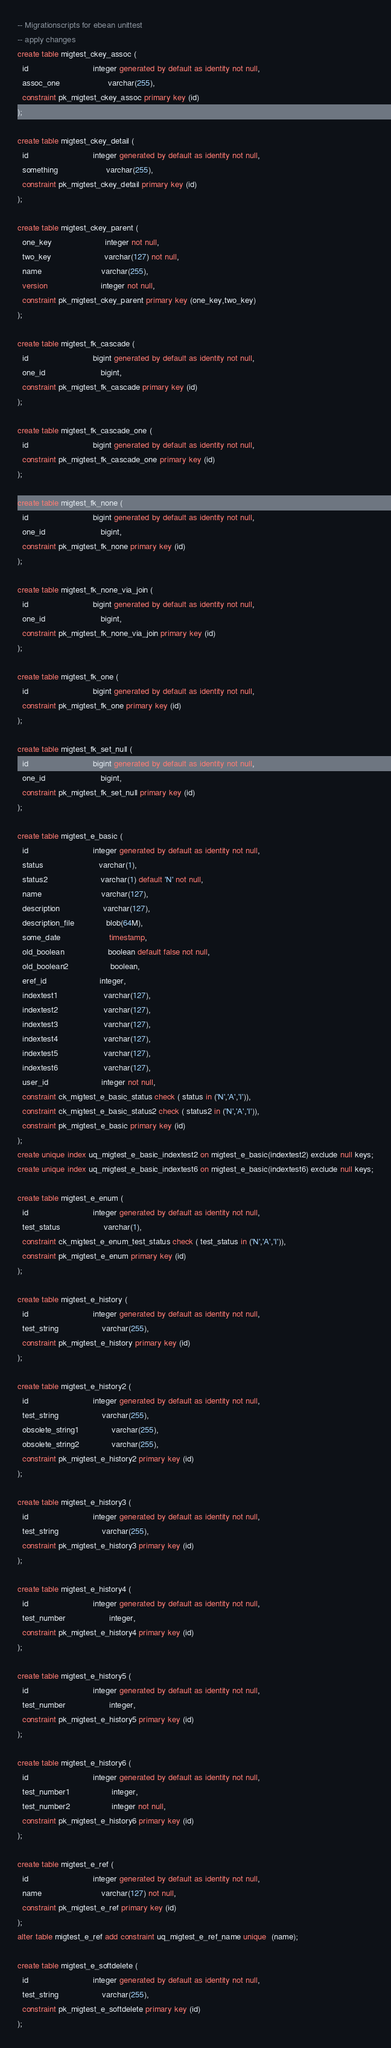<code> <loc_0><loc_0><loc_500><loc_500><_SQL_>-- Migrationscripts for ebean unittest
-- apply changes
create table migtest_ckey_assoc (
  id                            integer generated by default as identity not null,
  assoc_one                     varchar(255),
  constraint pk_migtest_ckey_assoc primary key (id)
);

create table migtest_ckey_detail (
  id                            integer generated by default as identity not null,
  something                     varchar(255),
  constraint pk_migtest_ckey_detail primary key (id)
);

create table migtest_ckey_parent (
  one_key                       integer not null,
  two_key                       varchar(127) not null,
  name                          varchar(255),
  version                       integer not null,
  constraint pk_migtest_ckey_parent primary key (one_key,two_key)
);

create table migtest_fk_cascade (
  id                            bigint generated by default as identity not null,
  one_id                        bigint,
  constraint pk_migtest_fk_cascade primary key (id)
);

create table migtest_fk_cascade_one (
  id                            bigint generated by default as identity not null,
  constraint pk_migtest_fk_cascade_one primary key (id)
);

create table migtest_fk_none (
  id                            bigint generated by default as identity not null,
  one_id                        bigint,
  constraint pk_migtest_fk_none primary key (id)
);

create table migtest_fk_none_via_join (
  id                            bigint generated by default as identity not null,
  one_id                        bigint,
  constraint pk_migtest_fk_none_via_join primary key (id)
);

create table migtest_fk_one (
  id                            bigint generated by default as identity not null,
  constraint pk_migtest_fk_one primary key (id)
);

create table migtest_fk_set_null (
  id                            bigint generated by default as identity not null,
  one_id                        bigint,
  constraint pk_migtest_fk_set_null primary key (id)
);

create table migtest_e_basic (
  id                            integer generated by default as identity not null,
  status                        varchar(1),
  status2                       varchar(1) default 'N' not null,
  name                          varchar(127),
  description                   varchar(127),
  description_file              blob(64M),
  some_date                     timestamp,
  old_boolean                   boolean default false not null,
  old_boolean2                  boolean,
  eref_id                       integer,
  indextest1                    varchar(127),
  indextest2                    varchar(127),
  indextest3                    varchar(127),
  indextest4                    varchar(127),
  indextest5                    varchar(127),
  indextest6                    varchar(127),
  user_id                       integer not null,
  constraint ck_migtest_e_basic_status check ( status in ('N','A','I')),
  constraint ck_migtest_e_basic_status2 check ( status2 in ('N','A','I')),
  constraint pk_migtest_e_basic primary key (id)
);
create unique index uq_migtest_e_basic_indextest2 on migtest_e_basic(indextest2) exclude null keys;
create unique index uq_migtest_e_basic_indextest6 on migtest_e_basic(indextest6) exclude null keys;

create table migtest_e_enum (
  id                            integer generated by default as identity not null,
  test_status                   varchar(1),
  constraint ck_migtest_e_enum_test_status check ( test_status in ('N','A','I')),
  constraint pk_migtest_e_enum primary key (id)
);

create table migtest_e_history (
  id                            integer generated by default as identity not null,
  test_string                   varchar(255),
  constraint pk_migtest_e_history primary key (id)
);

create table migtest_e_history2 (
  id                            integer generated by default as identity not null,
  test_string                   varchar(255),
  obsolete_string1              varchar(255),
  obsolete_string2              varchar(255),
  constraint pk_migtest_e_history2 primary key (id)
);

create table migtest_e_history3 (
  id                            integer generated by default as identity not null,
  test_string                   varchar(255),
  constraint pk_migtest_e_history3 primary key (id)
);

create table migtest_e_history4 (
  id                            integer generated by default as identity not null,
  test_number                   integer,
  constraint pk_migtest_e_history4 primary key (id)
);

create table migtest_e_history5 (
  id                            integer generated by default as identity not null,
  test_number                   integer,
  constraint pk_migtest_e_history5 primary key (id)
);

create table migtest_e_history6 (
  id                            integer generated by default as identity not null,
  test_number1                  integer,
  test_number2                  integer not null,
  constraint pk_migtest_e_history6 primary key (id)
);

create table migtest_e_ref (
  id                            integer generated by default as identity not null,
  name                          varchar(127) not null,
  constraint pk_migtest_e_ref primary key (id)
);
alter table migtest_e_ref add constraint uq_migtest_e_ref_name unique  (name);

create table migtest_e_softdelete (
  id                            integer generated by default as identity not null,
  test_string                   varchar(255),
  constraint pk_migtest_e_softdelete primary key (id)
);
</code> 